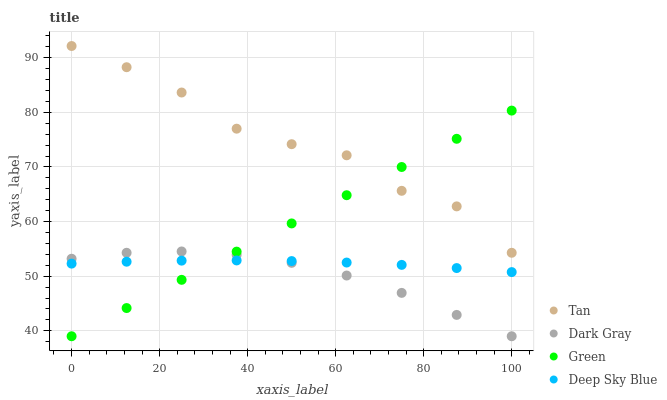Does Dark Gray have the minimum area under the curve?
Answer yes or no. Yes. Does Tan have the maximum area under the curve?
Answer yes or no. Yes. Does Green have the minimum area under the curve?
Answer yes or no. No. Does Green have the maximum area under the curve?
Answer yes or no. No. Is Green the smoothest?
Answer yes or no. Yes. Is Tan the roughest?
Answer yes or no. Yes. Is Tan the smoothest?
Answer yes or no. No. Is Green the roughest?
Answer yes or no. No. Does Dark Gray have the lowest value?
Answer yes or no. Yes. Does Tan have the lowest value?
Answer yes or no. No. Does Tan have the highest value?
Answer yes or no. Yes. Does Green have the highest value?
Answer yes or no. No. Is Deep Sky Blue less than Tan?
Answer yes or no. Yes. Is Tan greater than Deep Sky Blue?
Answer yes or no. Yes. Does Tan intersect Green?
Answer yes or no. Yes. Is Tan less than Green?
Answer yes or no. No. Is Tan greater than Green?
Answer yes or no. No. Does Deep Sky Blue intersect Tan?
Answer yes or no. No. 